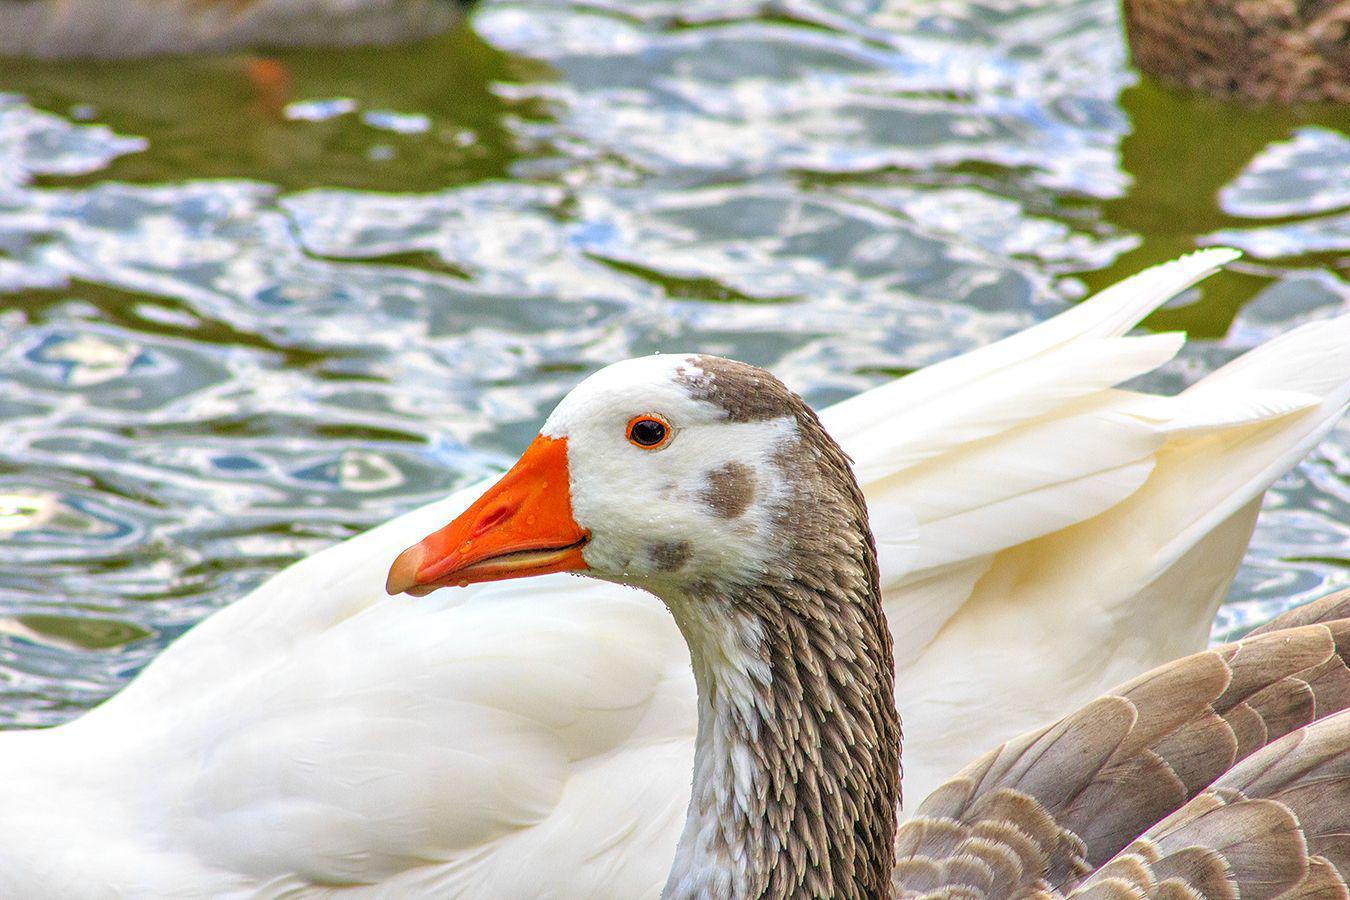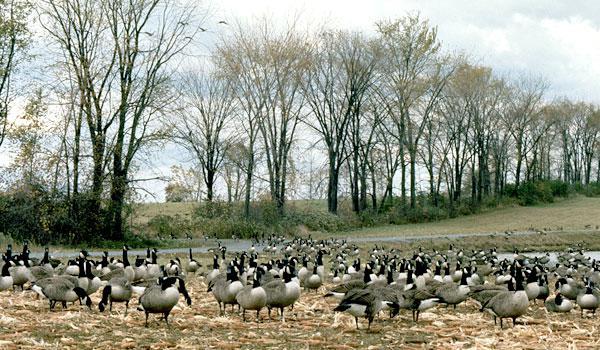The first image is the image on the left, the second image is the image on the right. Given the left and right images, does the statement "In at least one image there is at least one black and grey duck facing right in the water." hold true? Answer yes or no. No. The first image is the image on the left, the second image is the image on the right. Evaluate the accuracy of this statement regarding the images: "The canada geese are in the water.". Is it true? Answer yes or no. No. 